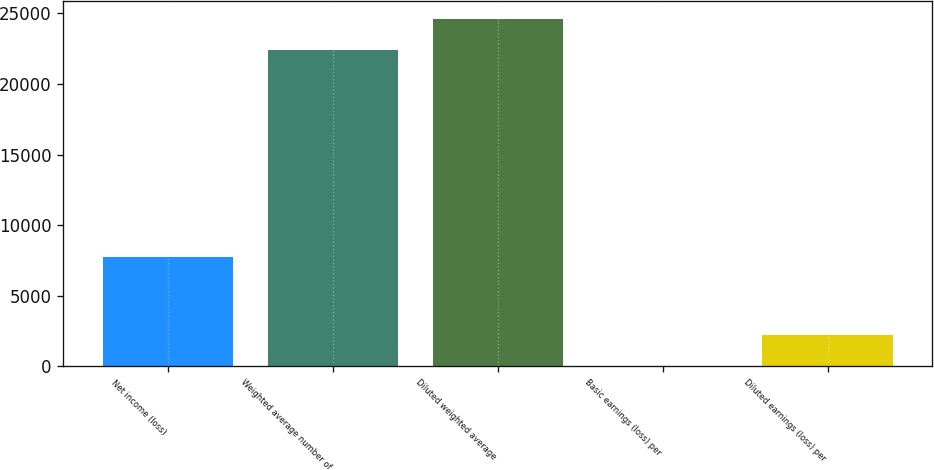Convert chart. <chart><loc_0><loc_0><loc_500><loc_500><bar_chart><fcel>Net income (loss)<fcel>Weighted average number of<fcel>Diluted weighted average<fcel>Basic earnings (loss) per<fcel>Diluted earnings (loss) per<nl><fcel>7714<fcel>22384<fcel>24622.4<fcel>0.34<fcel>2238.71<nl></chart> 